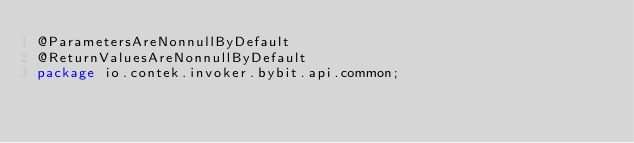Convert code to text. <code><loc_0><loc_0><loc_500><loc_500><_Java_>@ParametersAreNonnullByDefault
@ReturnValuesAreNonnullByDefault
package io.contek.invoker.bybit.api.common;
</code> 